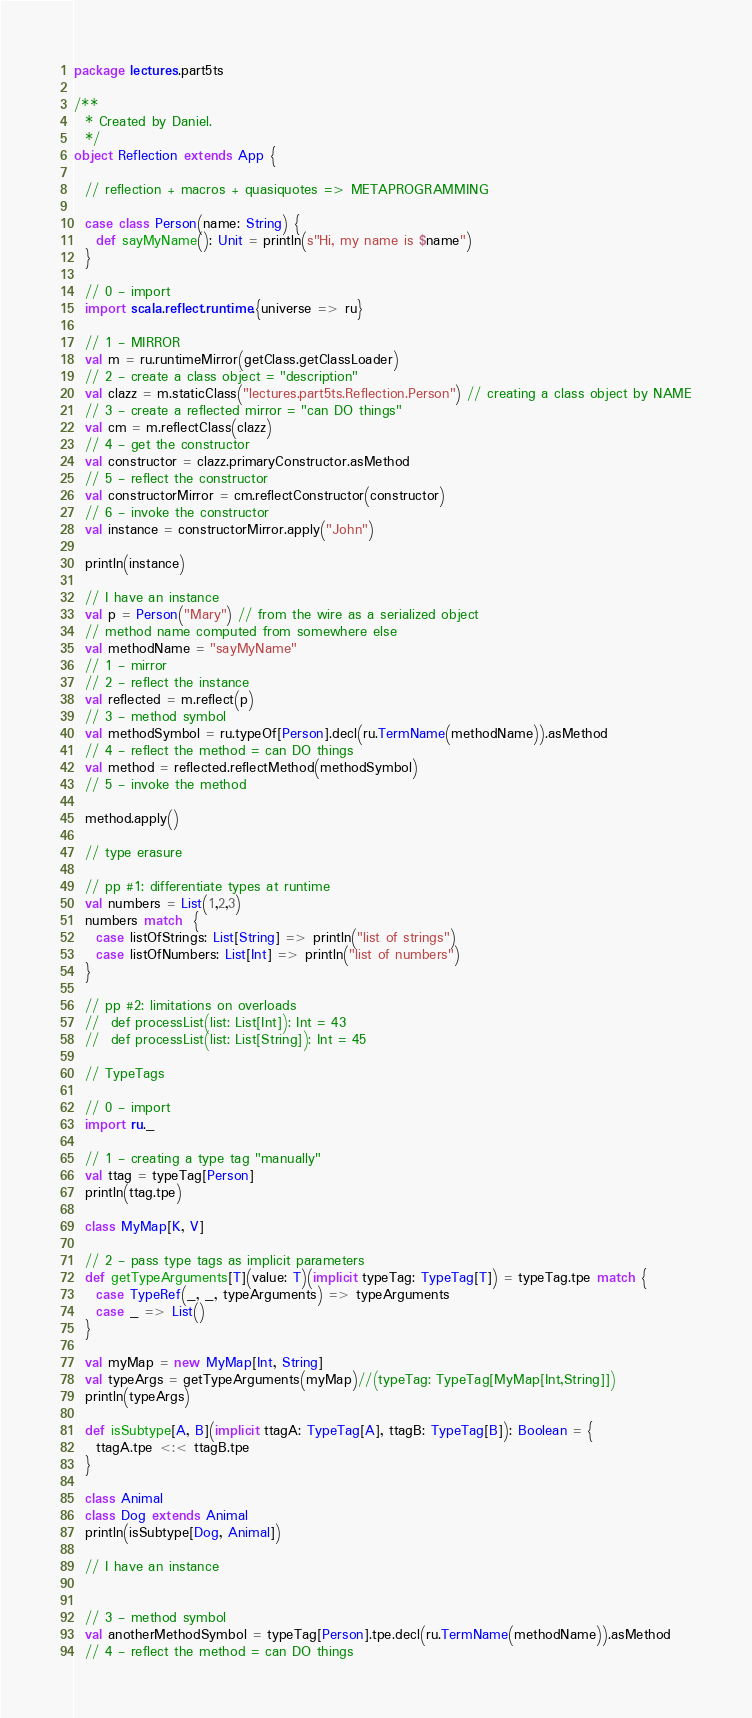Convert code to text. <code><loc_0><loc_0><loc_500><loc_500><_Scala_>package lectures.part5ts

/**
  * Created by Daniel.
  */
object Reflection extends App {

  // reflection + macros + quasiquotes => METAPROGRAMMING

  case class Person(name: String) {
    def sayMyName(): Unit = println(s"Hi, my name is $name")
  }

  // 0 - import
  import scala.reflect.runtime.{universe => ru}

  // 1 - MIRROR
  val m = ru.runtimeMirror(getClass.getClassLoader)
  // 2 - create a class object = "description"
  val clazz = m.staticClass("lectures.part5ts.Reflection.Person") // creating a class object by NAME
  // 3 - create a reflected mirror = "can DO things"
  val cm = m.reflectClass(clazz)
  // 4 - get the constructor
  val constructor = clazz.primaryConstructor.asMethod
  // 5 - reflect the constructor
  val constructorMirror = cm.reflectConstructor(constructor)
  // 6 - invoke the constructor
  val instance = constructorMirror.apply("John")

  println(instance)

  // I have an instance
  val p = Person("Mary") // from the wire as a serialized object
  // method name computed from somewhere else
  val methodName = "sayMyName"
  // 1 - mirror
  // 2 - reflect the instance
  val reflected = m.reflect(p)
  // 3 - method symbol
  val methodSymbol = ru.typeOf[Person].decl(ru.TermName(methodName)).asMethod
  // 4 - reflect the method = can DO things
  val method = reflected.reflectMethod(methodSymbol)
  // 5 - invoke the method

  method.apply()

  // type erasure

  // pp #1: differentiate types at runtime
  val numbers = List(1,2,3)
  numbers match  {
    case listOfStrings: List[String] => println("list of strings")
    case listOfNumbers: List[Int] => println("list of numbers")
  }

  // pp #2: limitations on overloads
  //  def processList(list: List[Int]): Int = 43
  //  def processList(list: List[String]): Int = 45

  // TypeTags

  // 0 - import
  import ru._

  // 1 - creating a type tag "manually"
  val ttag = typeTag[Person]
  println(ttag.tpe)

  class MyMap[K, V]

  // 2 - pass type tags as implicit parameters
  def getTypeArguments[T](value: T)(implicit typeTag: TypeTag[T]) = typeTag.tpe match {
    case TypeRef(_, _, typeArguments) => typeArguments
    case _ => List()
  }

  val myMap = new MyMap[Int, String]
  val typeArgs = getTypeArguments(myMap)//(typeTag: TypeTag[MyMap[Int,String]])
  println(typeArgs)

  def isSubtype[A, B](implicit ttagA: TypeTag[A], ttagB: TypeTag[B]): Boolean = {
    ttagA.tpe <:< ttagB.tpe
  }

  class Animal
  class Dog extends Animal
  println(isSubtype[Dog, Animal])

  // I have an instance


  // 3 - method symbol
  val anotherMethodSymbol = typeTag[Person].tpe.decl(ru.TermName(methodName)).asMethod
  // 4 - reflect the method = can DO things</code> 